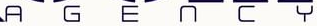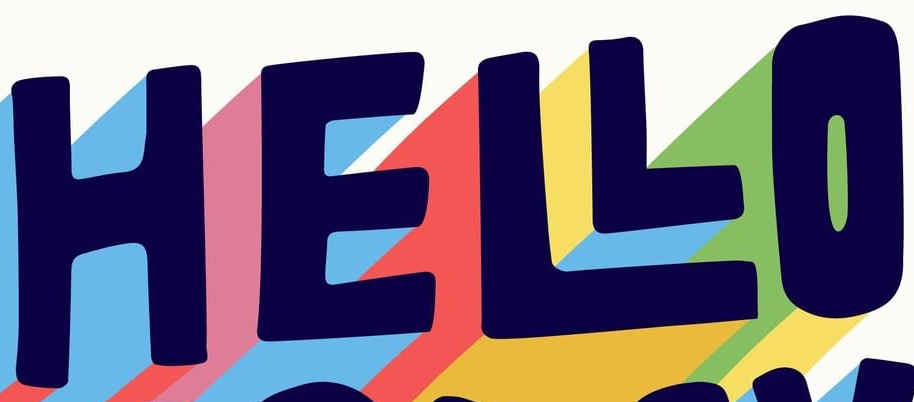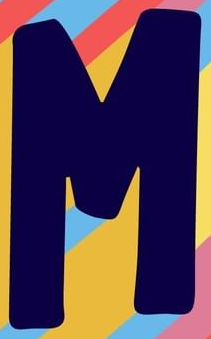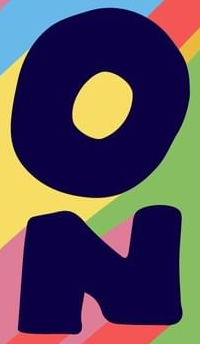What words can you see in these images in sequence, separated by a semicolon? AGENCY; HELLO; M; ON 